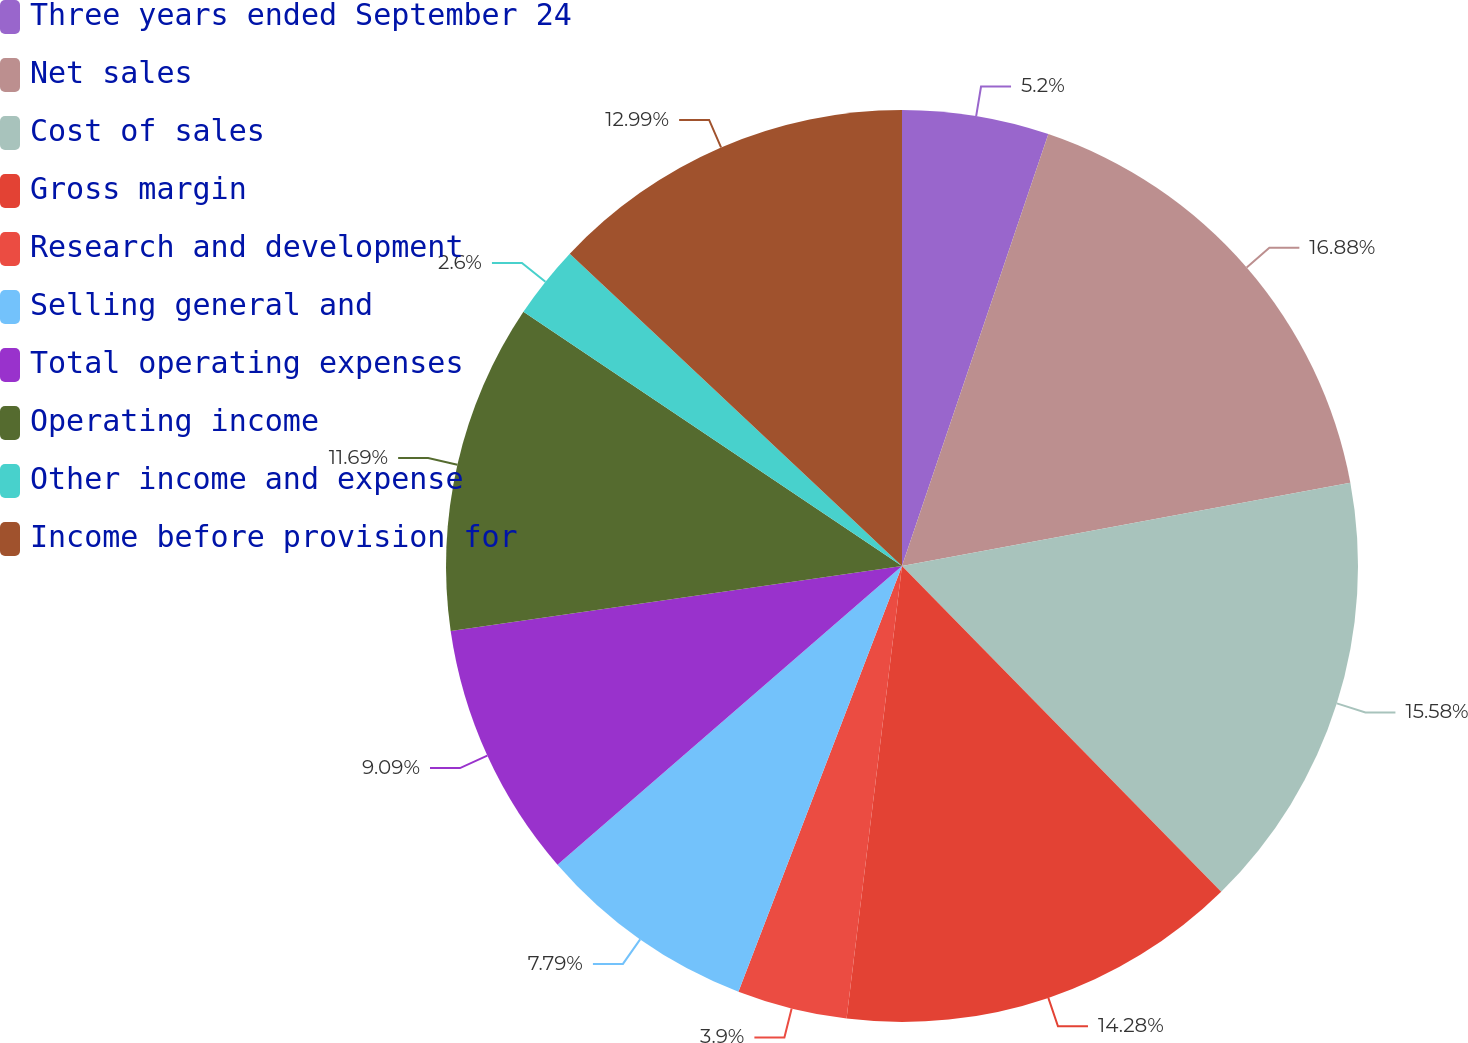Convert chart to OTSL. <chart><loc_0><loc_0><loc_500><loc_500><pie_chart><fcel>Three years ended September 24<fcel>Net sales<fcel>Cost of sales<fcel>Gross margin<fcel>Research and development<fcel>Selling general and<fcel>Total operating expenses<fcel>Operating income<fcel>Other income and expense<fcel>Income before provision for<nl><fcel>5.2%<fcel>16.88%<fcel>15.58%<fcel>14.28%<fcel>3.9%<fcel>7.79%<fcel>9.09%<fcel>11.69%<fcel>2.6%<fcel>12.99%<nl></chart> 